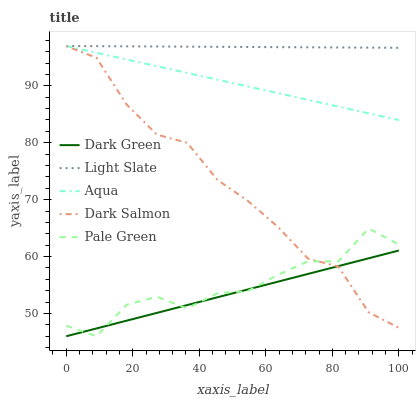Does Dark Green have the minimum area under the curve?
Answer yes or no. Yes. Does Light Slate have the maximum area under the curve?
Answer yes or no. Yes. Does Pale Green have the minimum area under the curve?
Answer yes or no. No. Does Pale Green have the maximum area under the curve?
Answer yes or no. No. Is Dark Green the smoothest?
Answer yes or no. Yes. Is Pale Green the roughest?
Answer yes or no. Yes. Is Aqua the smoothest?
Answer yes or no. No. Is Aqua the roughest?
Answer yes or no. No. Does Pale Green have the lowest value?
Answer yes or no. Yes. Does Aqua have the lowest value?
Answer yes or no. No. Does Aqua have the highest value?
Answer yes or no. Yes. Does Pale Green have the highest value?
Answer yes or no. No. Is Pale Green less than Light Slate?
Answer yes or no. Yes. Is Aqua greater than Pale Green?
Answer yes or no. Yes. Does Dark Salmon intersect Dark Green?
Answer yes or no. Yes. Is Dark Salmon less than Dark Green?
Answer yes or no. No. Is Dark Salmon greater than Dark Green?
Answer yes or no. No. Does Pale Green intersect Light Slate?
Answer yes or no. No. 